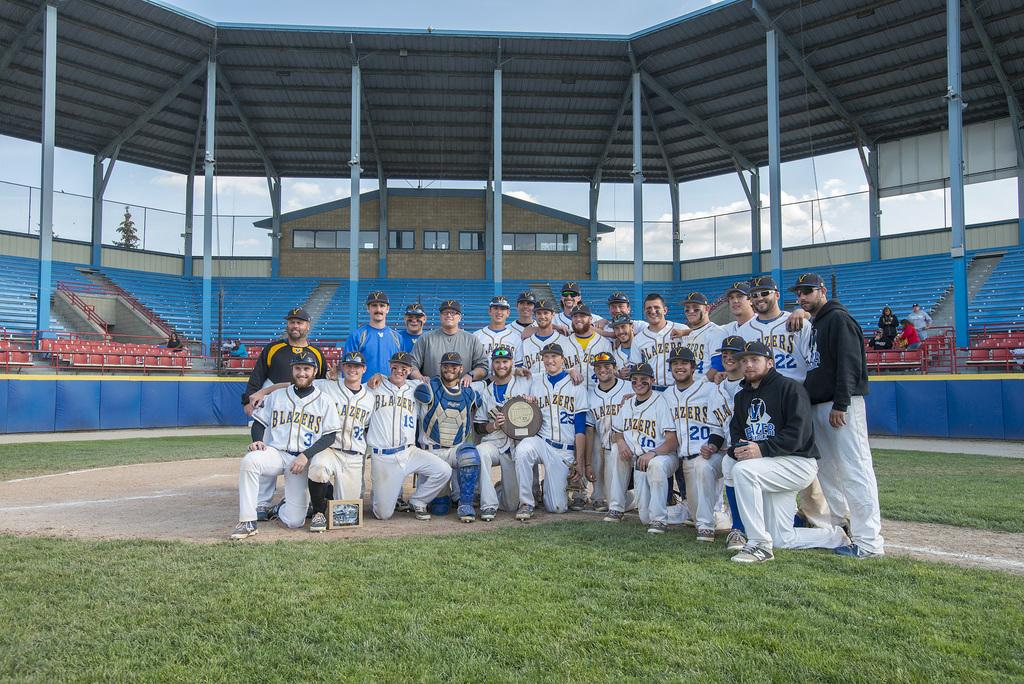Provide a one-sentence caption for the provided image. Lazers Jersey with numbers ten, nineteen, and thirty two designed on them. 